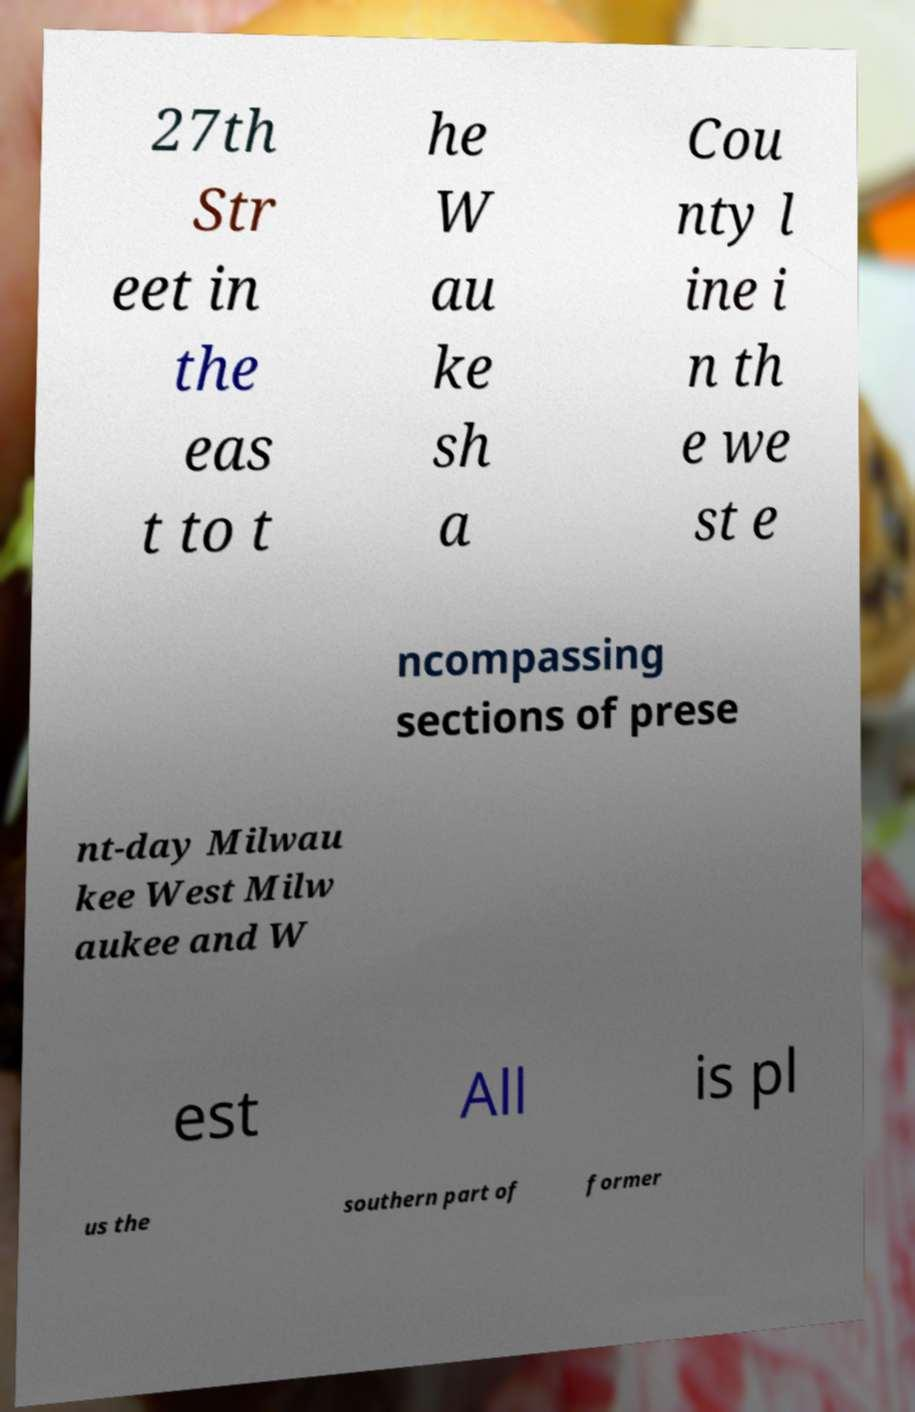Could you extract and type out the text from this image? 27th Str eet in the eas t to t he W au ke sh a Cou nty l ine i n th e we st e ncompassing sections of prese nt-day Milwau kee West Milw aukee and W est All is pl us the southern part of former 